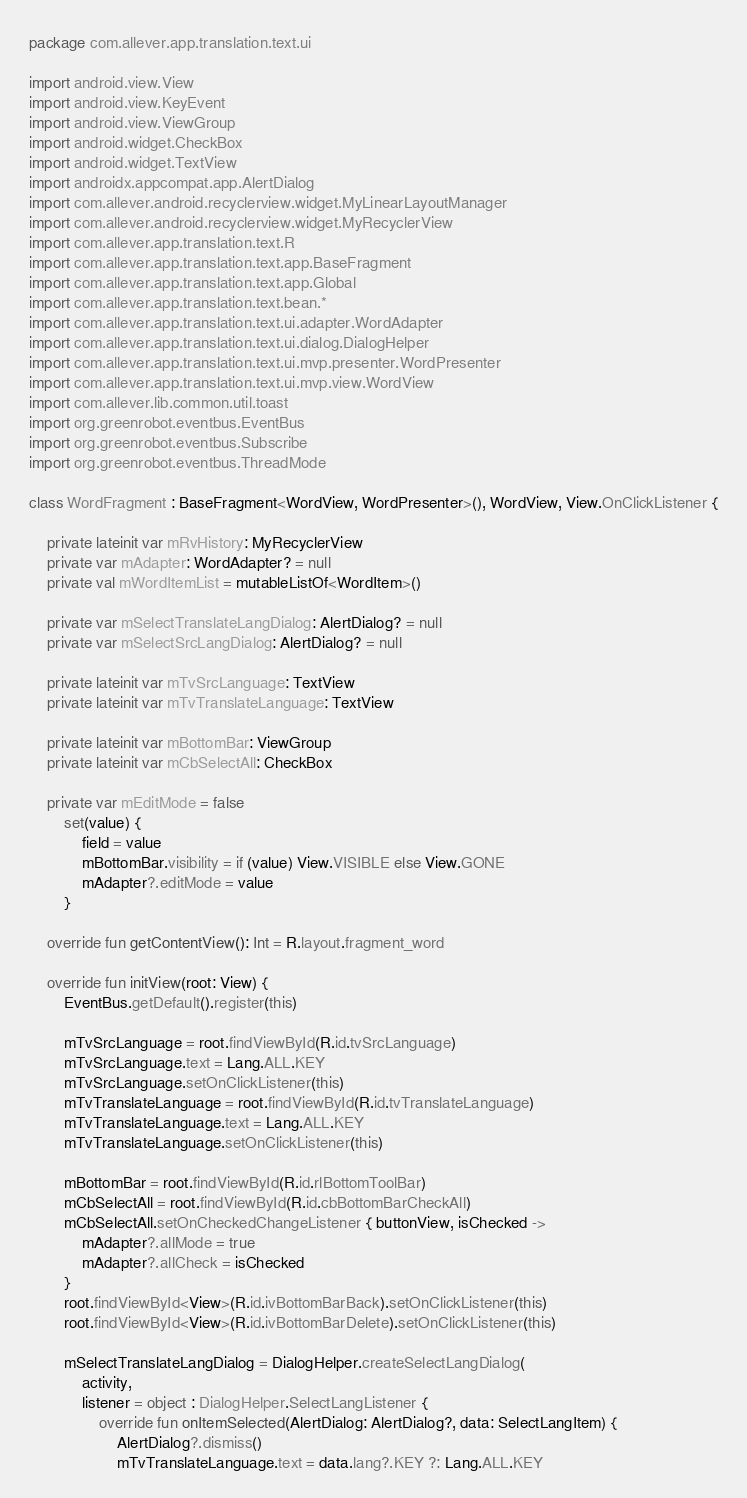<code> <loc_0><loc_0><loc_500><loc_500><_Kotlin_>package com.allever.app.translation.text.ui

import android.view.View
import android.view.KeyEvent
import android.view.ViewGroup
import android.widget.CheckBox
import android.widget.TextView
import androidx.appcompat.app.AlertDialog
import com.allever.android.recyclerview.widget.MyLinearLayoutManager
import com.allever.android.recyclerview.widget.MyRecyclerView
import com.allever.app.translation.text.R
import com.allever.app.translation.text.app.BaseFragment
import com.allever.app.translation.text.app.Global
import com.allever.app.translation.text.bean.*
import com.allever.app.translation.text.ui.adapter.WordAdapter
import com.allever.app.translation.text.ui.dialog.DialogHelper
import com.allever.app.translation.text.ui.mvp.presenter.WordPresenter
import com.allever.app.translation.text.ui.mvp.view.WordView
import com.allever.lib.common.util.toast
import org.greenrobot.eventbus.EventBus
import org.greenrobot.eventbus.Subscribe
import org.greenrobot.eventbus.ThreadMode

class WordFragment : BaseFragment<WordView, WordPresenter>(), WordView, View.OnClickListener {

    private lateinit var mRvHistory: MyRecyclerView
    private var mAdapter: WordAdapter? = null
    private val mWordItemList = mutableListOf<WordItem>()

    private var mSelectTranslateLangDialog: AlertDialog? = null
    private var mSelectSrcLangDialog: AlertDialog? = null

    private lateinit var mTvSrcLanguage: TextView
    private lateinit var mTvTranslateLanguage: TextView

    private lateinit var mBottomBar: ViewGroup
    private lateinit var mCbSelectAll: CheckBox

    private var mEditMode = false
        set(value) {
            field = value
            mBottomBar.visibility = if (value) View.VISIBLE else View.GONE
            mAdapter?.editMode = value
        }

    override fun getContentView(): Int = R.layout.fragment_word

    override fun initView(root: View) {
        EventBus.getDefault().register(this)

        mTvSrcLanguage = root.findViewById(R.id.tvSrcLanguage)
        mTvSrcLanguage.text = Lang.ALL.KEY
        mTvSrcLanguage.setOnClickListener(this)
        mTvTranslateLanguage = root.findViewById(R.id.tvTranslateLanguage)
        mTvTranslateLanguage.text = Lang.ALL.KEY
        mTvTranslateLanguage.setOnClickListener(this)

        mBottomBar = root.findViewById(R.id.rlBottomToolBar)
        mCbSelectAll = root.findViewById(R.id.cbBottomBarCheckAll)
        mCbSelectAll.setOnCheckedChangeListener { buttonView, isChecked ->
            mAdapter?.allMode = true
            mAdapter?.allCheck = isChecked
        }
        root.findViewById<View>(R.id.ivBottomBarBack).setOnClickListener(this)
        root.findViewById<View>(R.id.ivBottomBarDelete).setOnClickListener(this)

        mSelectTranslateLangDialog = DialogHelper.createSelectLangDialog(
            activity,
            listener = object : DialogHelper.SelectLangListener {
                override fun onItemSelected(AlertDialog: AlertDialog?, data: SelectLangItem) {
                    AlertDialog?.dismiss()
                    mTvTranslateLanguage.text = data.lang?.KEY ?: Lang.ALL.KEY</code> 